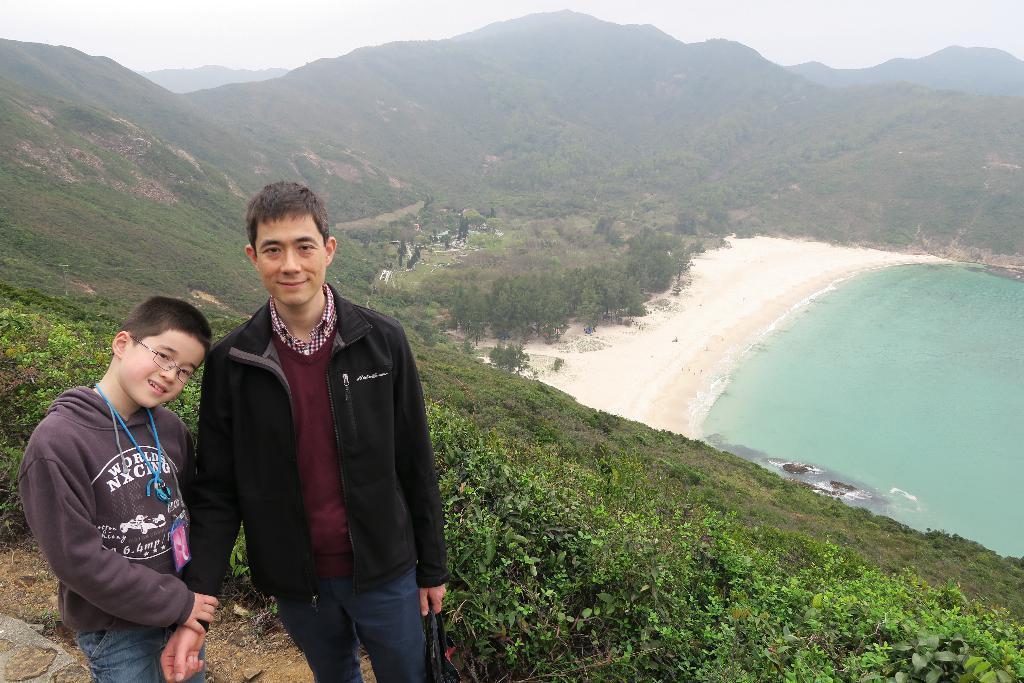Please provide a concise description of this image. In this picture, we can see there are two people standing and behind the people there is a water, trees, hills, fog and a sky. 